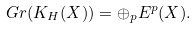<formula> <loc_0><loc_0><loc_500><loc_500>\ G r ( K _ { H } ( X ) ) = \oplus _ { p } E ^ { p } ( X ) .</formula> 